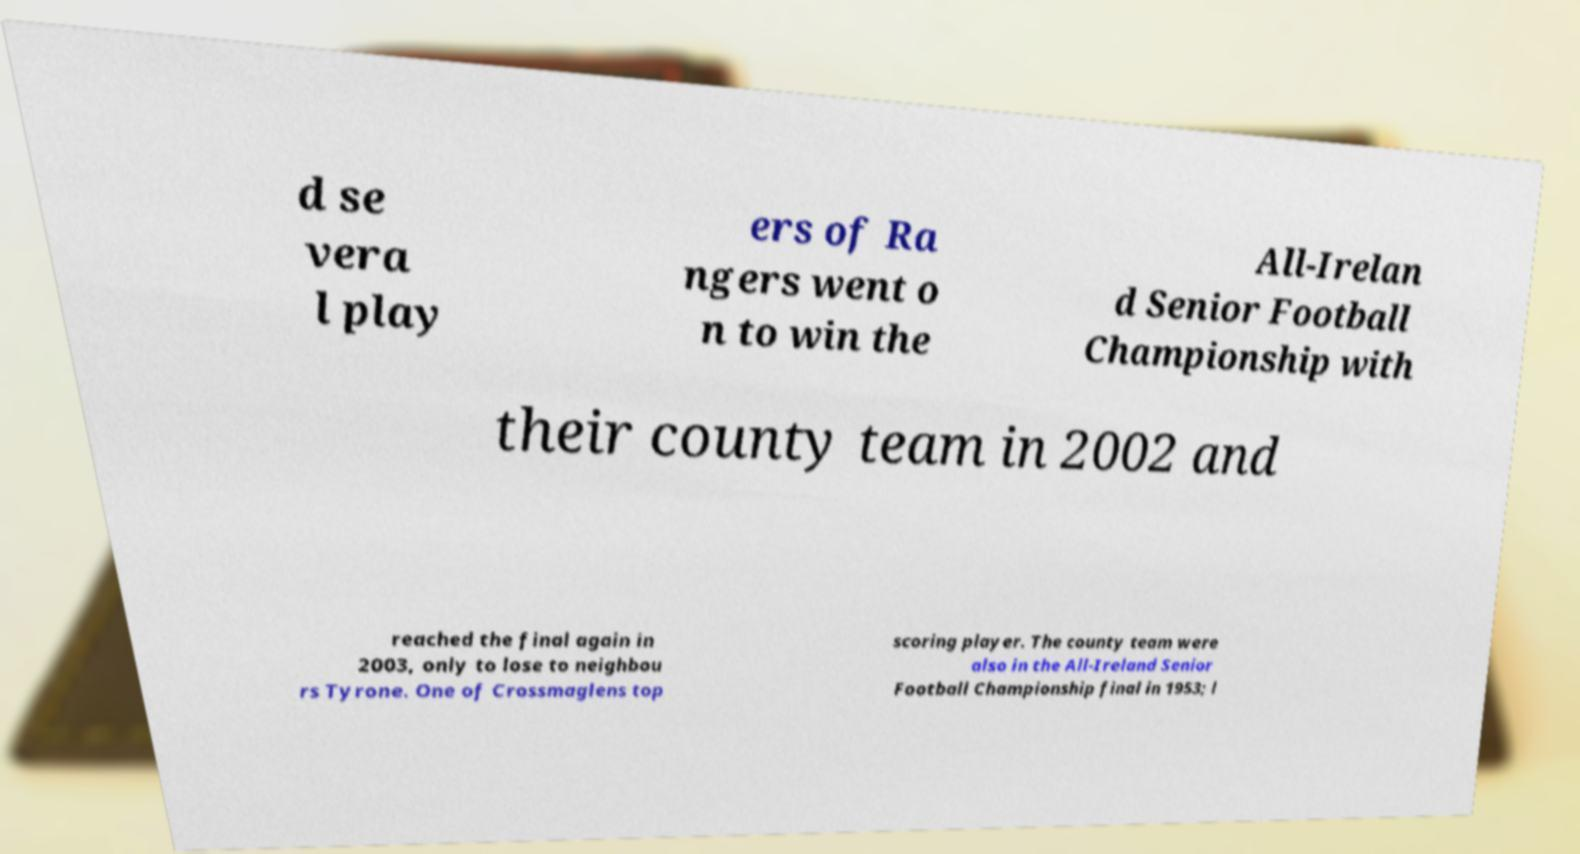Please identify and transcribe the text found in this image. d se vera l play ers of Ra ngers went o n to win the All-Irelan d Senior Football Championship with their county team in 2002 and reached the final again in 2003, only to lose to neighbou rs Tyrone. One of Crossmaglens top scoring player. The county team were also in the All-Ireland Senior Football Championship final in 1953; l 